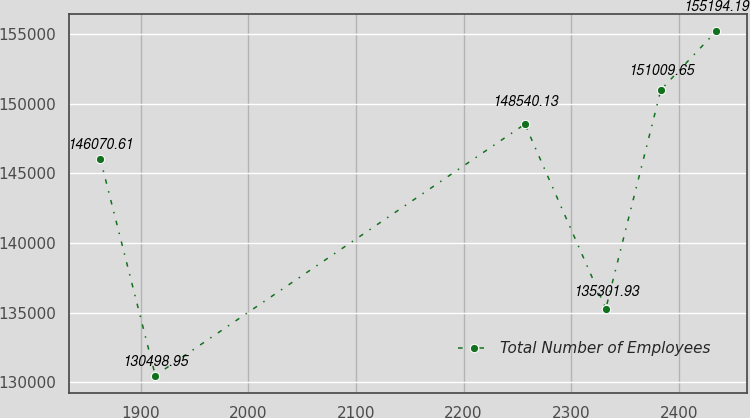Convert chart. <chart><loc_0><loc_0><loc_500><loc_500><line_chart><ecel><fcel>Total Number of Employees<nl><fcel>1862.52<fcel>146071<nl><fcel>1913.67<fcel>130499<nl><fcel>2256.91<fcel>148540<nl><fcel>2332.07<fcel>135302<nl><fcel>2383.22<fcel>151010<nl><fcel>2434.37<fcel>155194<nl></chart> 